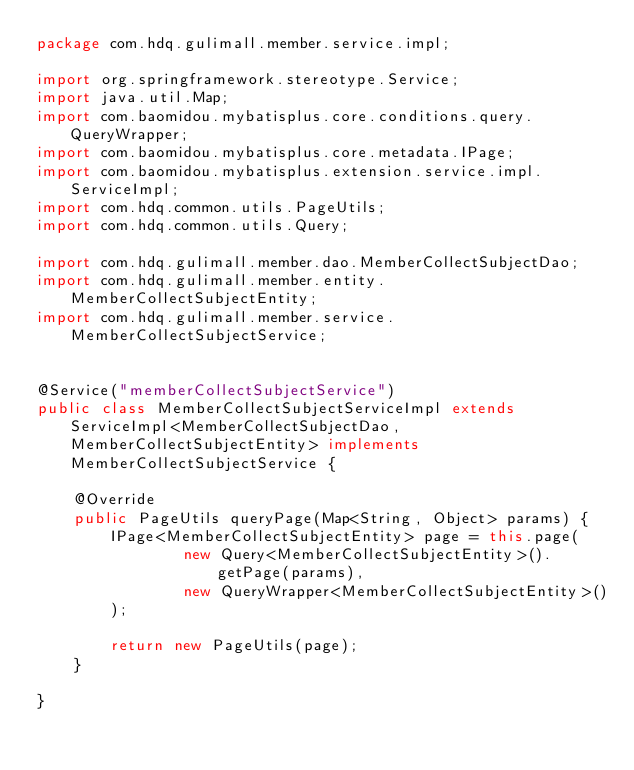Convert code to text. <code><loc_0><loc_0><loc_500><loc_500><_Java_>package com.hdq.gulimall.member.service.impl;

import org.springframework.stereotype.Service;
import java.util.Map;
import com.baomidou.mybatisplus.core.conditions.query.QueryWrapper;
import com.baomidou.mybatisplus.core.metadata.IPage;
import com.baomidou.mybatisplus.extension.service.impl.ServiceImpl;
import com.hdq.common.utils.PageUtils;
import com.hdq.common.utils.Query;

import com.hdq.gulimall.member.dao.MemberCollectSubjectDao;
import com.hdq.gulimall.member.entity.MemberCollectSubjectEntity;
import com.hdq.gulimall.member.service.MemberCollectSubjectService;


@Service("memberCollectSubjectService")
public class MemberCollectSubjectServiceImpl extends ServiceImpl<MemberCollectSubjectDao, MemberCollectSubjectEntity> implements MemberCollectSubjectService {

    @Override
    public PageUtils queryPage(Map<String, Object> params) {
        IPage<MemberCollectSubjectEntity> page = this.page(
                new Query<MemberCollectSubjectEntity>().getPage(params),
                new QueryWrapper<MemberCollectSubjectEntity>()
        );

        return new PageUtils(page);
    }

}</code> 